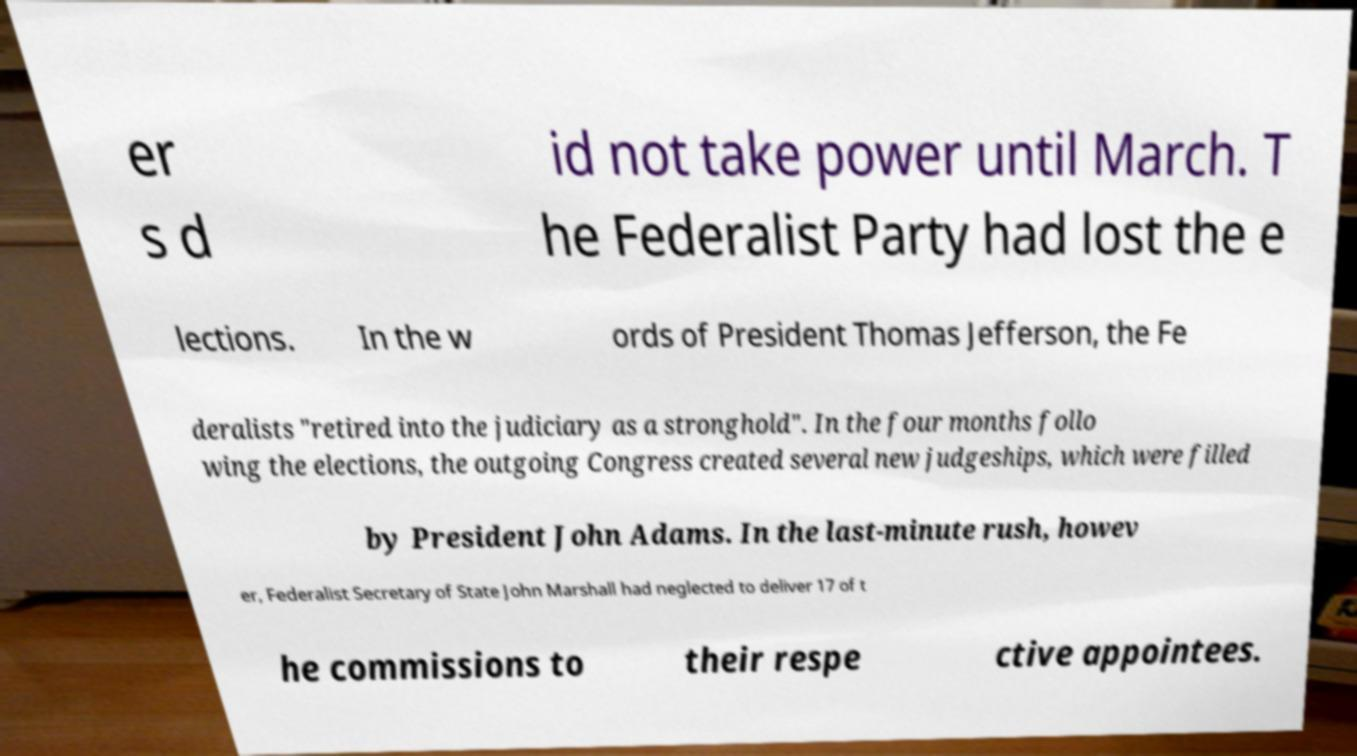Could you assist in decoding the text presented in this image and type it out clearly? er s d id not take power until March. T he Federalist Party had lost the e lections. In the w ords of President Thomas Jefferson, the Fe deralists "retired into the judiciary as a stronghold". In the four months follo wing the elections, the outgoing Congress created several new judgeships, which were filled by President John Adams. In the last-minute rush, howev er, Federalist Secretary of State John Marshall had neglected to deliver 17 of t he commissions to their respe ctive appointees. 